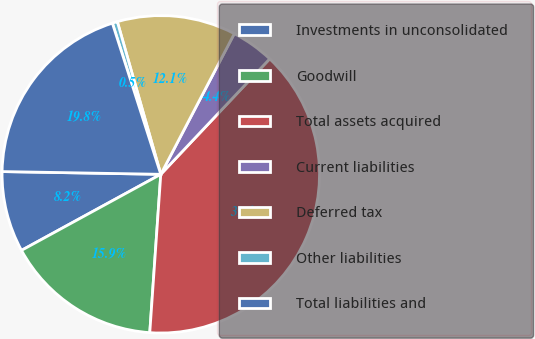<chart> <loc_0><loc_0><loc_500><loc_500><pie_chart><fcel>Investments in unconsolidated<fcel>Goodwill<fcel>Total assets acquired<fcel>Current liabilities<fcel>Deferred tax<fcel>Other liabilities<fcel>Total liabilities and<nl><fcel>8.23%<fcel>15.94%<fcel>39.07%<fcel>4.37%<fcel>12.08%<fcel>0.52%<fcel>19.79%<nl></chart> 